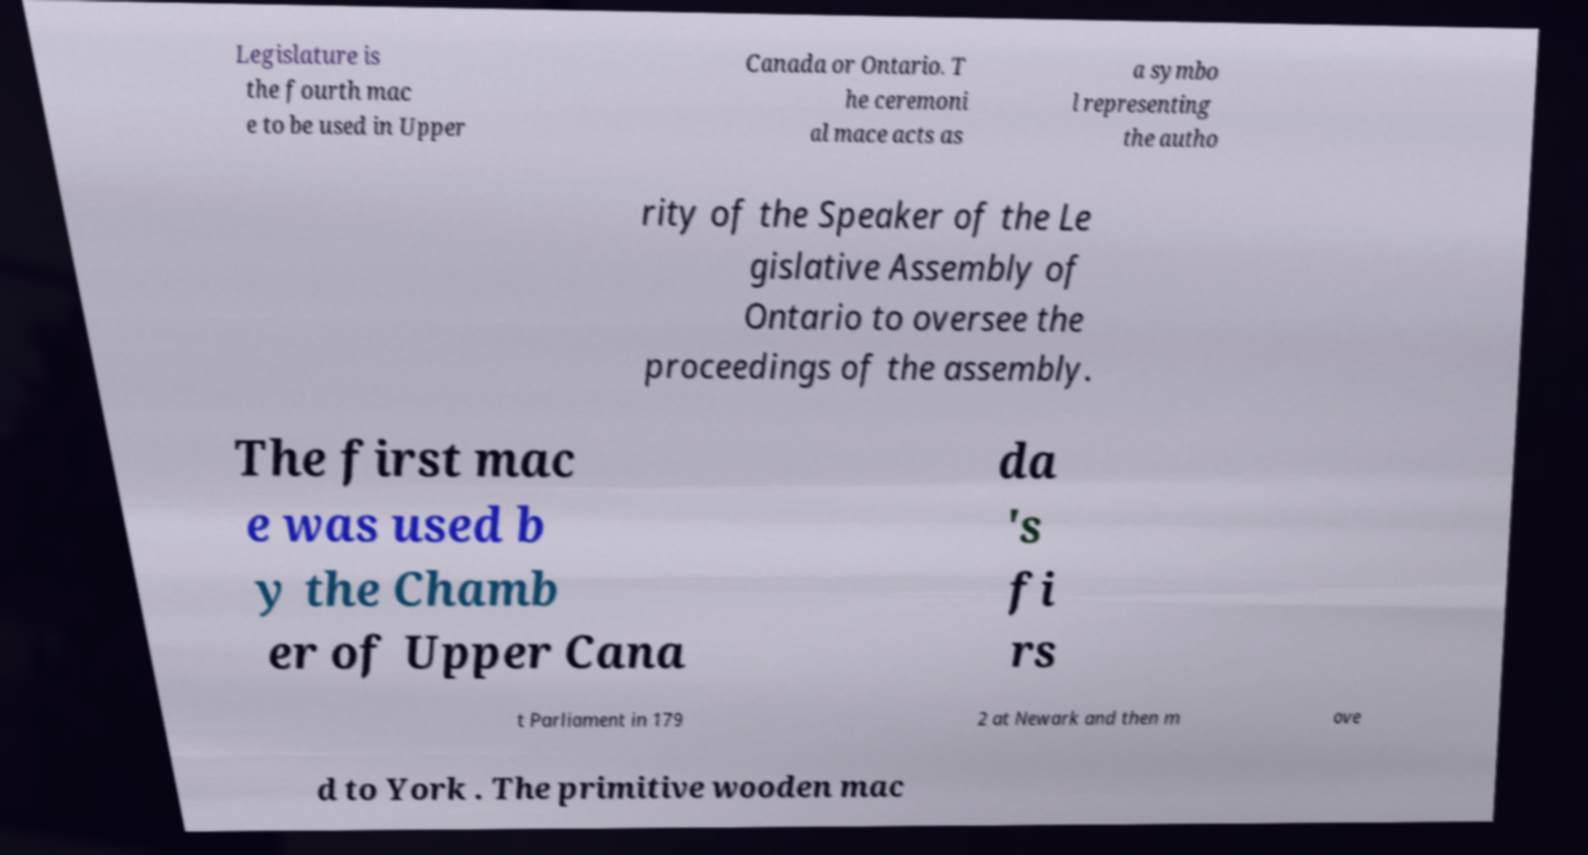Can you accurately transcribe the text from the provided image for me? Legislature is the fourth mac e to be used in Upper Canada or Ontario. T he ceremoni al mace acts as a symbo l representing the autho rity of the Speaker of the Le gislative Assembly of Ontario to oversee the proceedings of the assembly. The first mac e was used b y the Chamb er of Upper Cana da 's fi rs t Parliament in 179 2 at Newark and then m ove d to York . The primitive wooden mac 